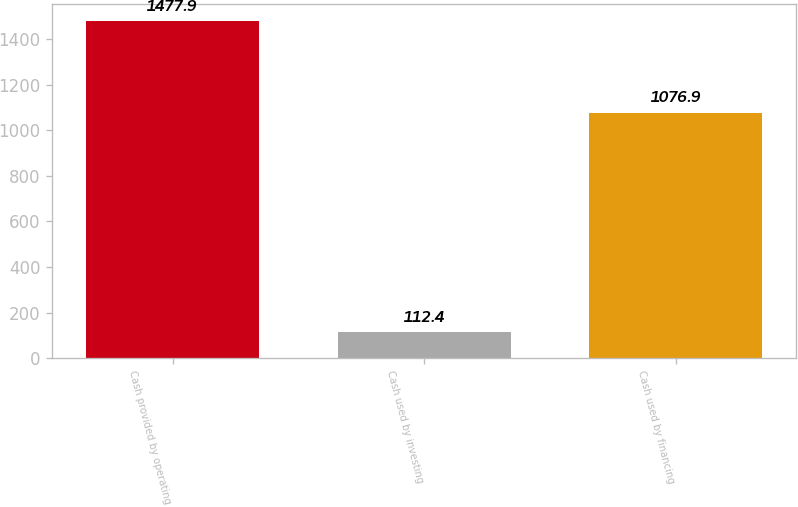Convert chart. <chart><loc_0><loc_0><loc_500><loc_500><bar_chart><fcel>Cash provided by operating<fcel>Cash used by investing<fcel>Cash used by financing<nl><fcel>1477.9<fcel>112.4<fcel>1076.9<nl></chart> 